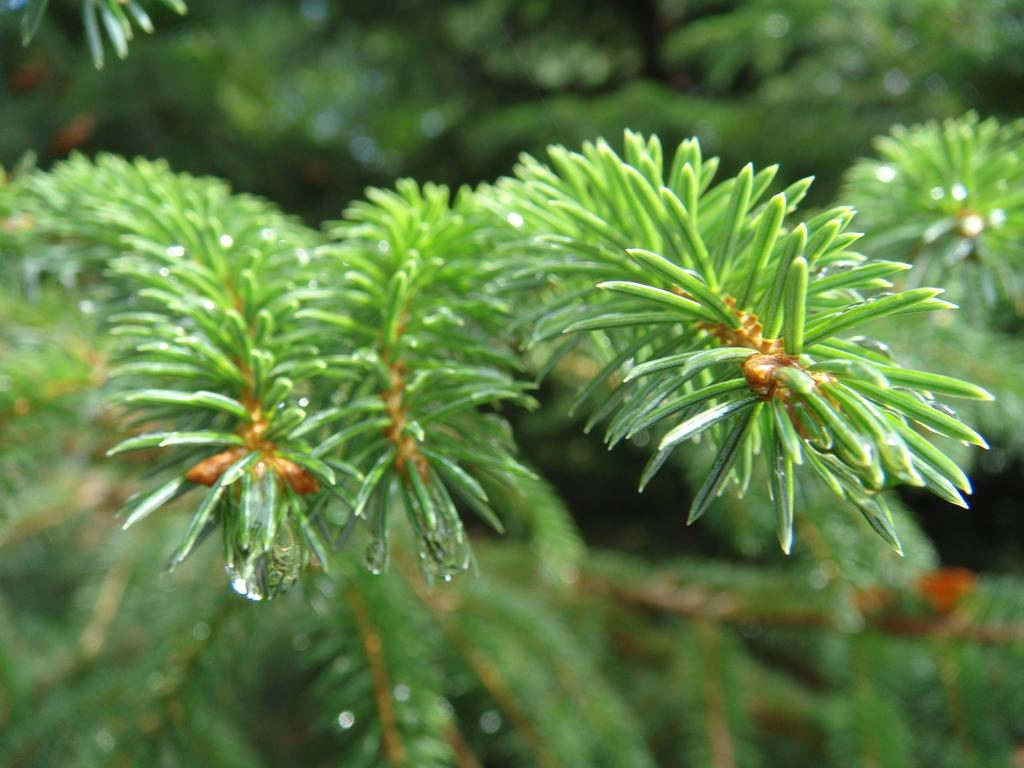What is the main subject of the image? The main subject of the image is the branches of a plant. Can you describe the background of the image? The background of the image is blurred. What type of sweater is hanging on the wall in the image? There is no sweater or wall present in the image; it only features branches of a plant with a blurred background. Can you see any worms crawling on the branches in the image? There are no worms visible on the branches in the image. 